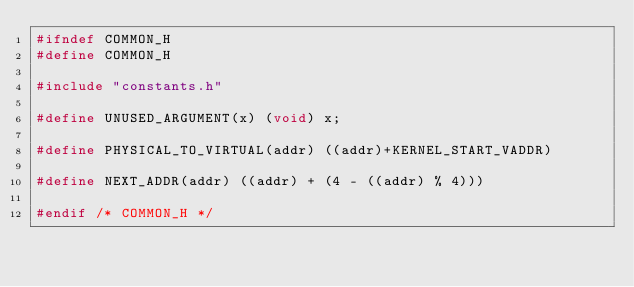Convert code to text. <code><loc_0><loc_0><loc_500><loc_500><_C_>#ifndef COMMON_H
#define COMMON_H

#include "constants.h"

#define UNUSED_ARGUMENT(x) (void) x;

#define PHYSICAL_TO_VIRTUAL(addr) ((addr)+KERNEL_START_VADDR)

#define NEXT_ADDR(addr) ((addr) + (4 - ((addr) % 4)))

#endif /* COMMON_H */
</code> 